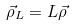<formula> <loc_0><loc_0><loc_500><loc_500>\vec { \rho } _ { L } = L \vec { \rho }</formula> 